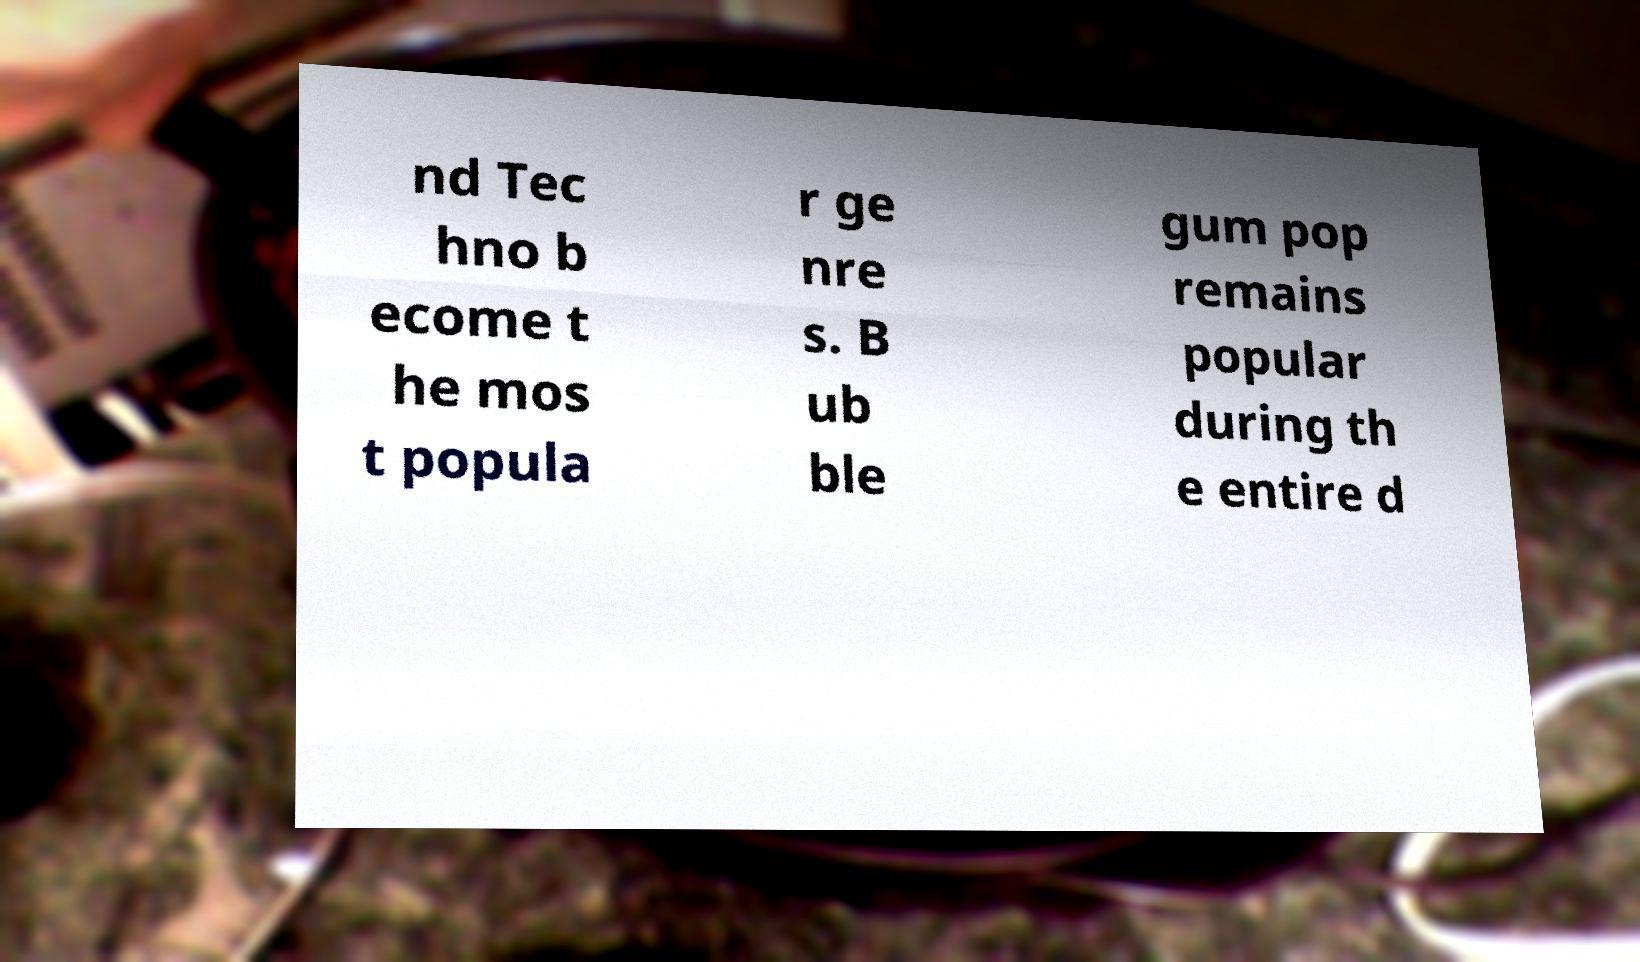What messages or text are displayed in this image? I need them in a readable, typed format. nd Tec hno b ecome t he mos t popula r ge nre s. B ub ble gum pop remains popular during th e entire d 